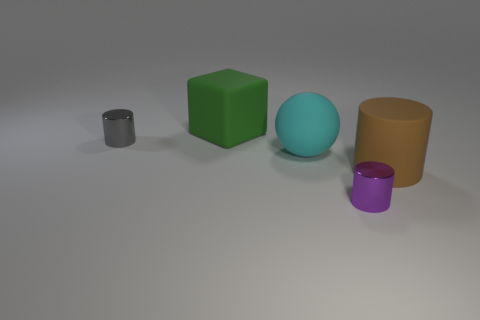Are there more blocks than green metallic things?
Your answer should be very brief. Yes. What size is the object that is made of the same material as the small purple cylinder?
Give a very brief answer. Small. Do the metal cylinder in front of the big cyan rubber object and the brown matte cylinder on the right side of the gray metallic cylinder have the same size?
Ensure brevity in your answer.  No. How many objects are small metal objects that are right of the gray cylinder or yellow rubber things?
Keep it short and to the point. 1. Is the number of small things less than the number of gray rubber objects?
Keep it short and to the point. No. What shape is the tiny thing to the left of the shiny thing that is on the right side of the tiny metallic object that is behind the cyan matte object?
Your response must be concise. Cylinder. Are any gray cylinders visible?
Offer a terse response. Yes. Is the size of the gray shiny thing the same as the object on the right side of the tiny purple metallic thing?
Give a very brief answer. No. There is a large rubber thing that is to the left of the cyan matte thing; is there a cylinder that is left of it?
Provide a short and direct response. Yes. What is the object that is both behind the cyan object and to the right of the gray cylinder made of?
Keep it short and to the point. Rubber. 